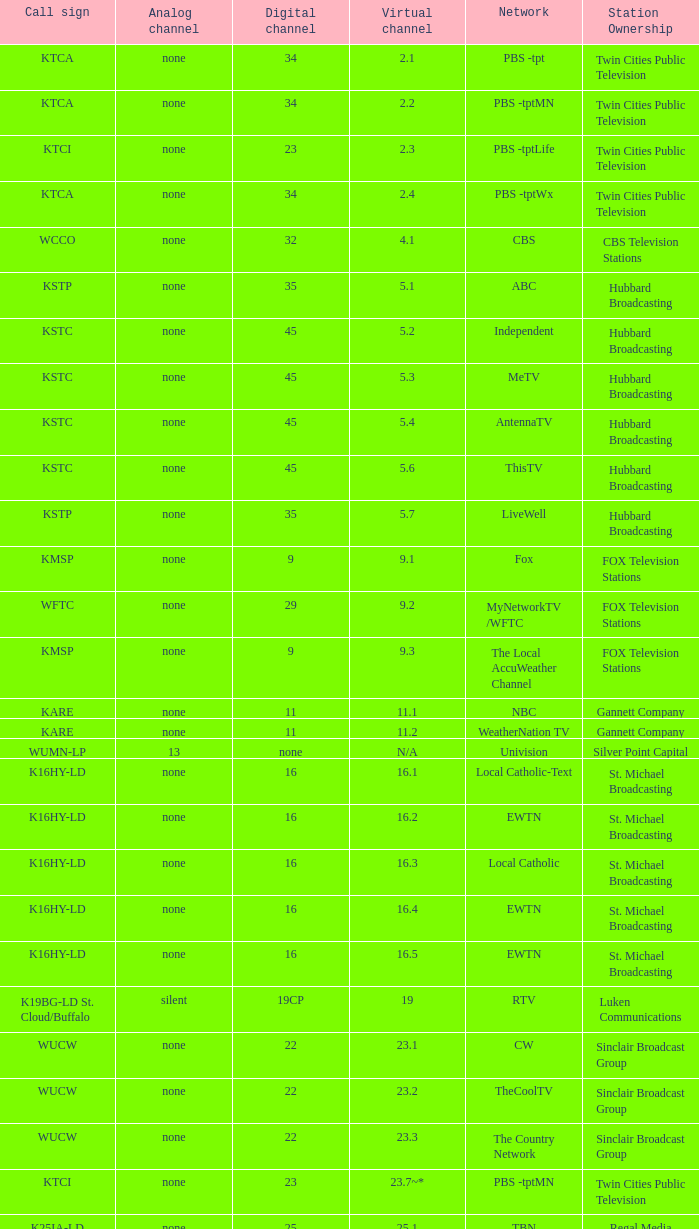Network of nbc is what digital channel? 11.0. Could you parse the entire table? {'header': ['Call sign', 'Analog channel', 'Digital channel', 'Virtual channel', 'Network', 'Station Ownership'], 'rows': [['KTCA', 'none', '34', '2.1', 'PBS -tpt', 'Twin Cities Public Television'], ['KTCA', 'none', '34', '2.2', 'PBS -tptMN', 'Twin Cities Public Television'], ['KTCI', 'none', '23', '2.3', 'PBS -tptLife', 'Twin Cities Public Television'], ['KTCA', 'none', '34', '2.4', 'PBS -tptWx', 'Twin Cities Public Television'], ['WCCO', 'none', '32', '4.1', 'CBS', 'CBS Television Stations'], ['KSTP', 'none', '35', '5.1', 'ABC', 'Hubbard Broadcasting'], ['KSTC', 'none', '45', '5.2', 'Independent', 'Hubbard Broadcasting'], ['KSTC', 'none', '45', '5.3', 'MeTV', 'Hubbard Broadcasting'], ['KSTC', 'none', '45', '5.4', 'AntennaTV', 'Hubbard Broadcasting'], ['KSTC', 'none', '45', '5.6', 'ThisTV', 'Hubbard Broadcasting'], ['KSTP', 'none', '35', '5.7', 'LiveWell', 'Hubbard Broadcasting'], ['KMSP', 'none', '9', '9.1', 'Fox', 'FOX Television Stations'], ['WFTC', 'none', '29', '9.2', 'MyNetworkTV /WFTC', 'FOX Television Stations'], ['KMSP', 'none', '9', '9.3', 'The Local AccuWeather Channel', 'FOX Television Stations'], ['KARE', 'none', '11', '11.1', 'NBC', 'Gannett Company'], ['KARE', 'none', '11', '11.2', 'WeatherNation TV', 'Gannett Company'], ['WUMN-LP', '13', 'none', 'N/A', 'Univision', 'Silver Point Capital'], ['K16HY-LD', 'none', '16', '16.1', 'Local Catholic-Text', 'St. Michael Broadcasting'], ['K16HY-LD', 'none', '16', '16.2', 'EWTN', 'St. Michael Broadcasting'], ['K16HY-LD', 'none', '16', '16.3', 'Local Catholic', 'St. Michael Broadcasting'], ['K16HY-LD', 'none', '16', '16.4', 'EWTN', 'St. Michael Broadcasting'], ['K16HY-LD', 'none', '16', '16.5', 'EWTN', 'St. Michael Broadcasting'], ['K19BG-LD St. Cloud/Buffalo', 'silent', '19CP', '19', 'RTV', 'Luken Communications'], ['WUCW', 'none', '22', '23.1', 'CW', 'Sinclair Broadcast Group'], ['WUCW', 'none', '22', '23.2', 'TheCoolTV', 'Sinclair Broadcast Group'], ['WUCW', 'none', '22', '23.3', 'The Country Network', 'Sinclair Broadcast Group'], ['KTCI', 'none', '23', '23.7~*', 'PBS -tptMN', 'Twin Cities Public Television'], ['K25IA-LD', 'none', '25', '25.1', 'TBN', 'Regal Media'], ['K25IA-LD', 'none', '25', '25.2', 'The Church Channel', 'Regal Media'], ['K25IA-LD', 'none', '25', '25.3', 'JCTV', 'Regal Media'], ['K25IA-LD', 'none', '25', '25.4', 'Smile Of A Child', 'Regal Media'], ['K25IA-LD', 'none', '25', '25.5', 'TBN Enlace', 'Regal Media'], ['W47CO-LD River Falls, Wisc.', 'none', '47', '28.1', 'PBS /WHWC', 'Wisconsin Public Television'], ['W47CO-LD River Falls, Wisc.', 'none', '47', '28.2', 'PBS -WISC/WHWC', 'Wisconsin Public Television'], ['W47CO-LD River Falls, Wisc.', 'none', '47', '28.3', 'PBS -Create/WHWC', 'Wisconsin Public Television'], ['WFTC', 'none', '29', '29.1', 'MyNetworkTV', 'FOX Television Stations'], ['KMSP', 'none', '9', '29.2', 'MyNetworkTV /WFTC', 'FOX Television Stations'], ['WFTC', 'none', '29', '29.3', 'Bounce TV', 'FOX Television Stations'], ['WFTC', 'none', '29', '29.4', 'Movies!', 'FOX Television Stations'], ['K33LN-LD', 'none', '33', '33.1', '3ABN', 'Three Angels Broadcasting Network'], ['K33LN-LD', 'none', '33', '33.2', '3ABN Proclaim!', 'Three Angels Broadcasting Network'], ['K33LN-LD', 'none', '33', '33.3', '3ABN Dare to Dream', 'Three Angels Broadcasting Network'], ['K33LN-LD', 'none', '33', '33.4', '3ABN Latino', 'Three Angels Broadcasting Network'], ['K33LN-LD', 'none', '33', '33.5', '3ABN Radio-Audio', 'Three Angels Broadcasting Network'], ['K33LN-LD', 'none', '33', '33.6', '3ABN Radio Latino-Audio', 'Three Angels Broadcasting Network'], ['K33LN-LD', 'none', '33', '33.7', 'Radio 74-Audio', 'Three Angels Broadcasting Network'], ['KPXM-TV', 'none', '40', '41.1', 'Ion Television', 'Ion Media Networks'], ['KPXM-TV', 'none', '40', '41.2', 'Qubo Kids', 'Ion Media Networks'], ['KPXM-TV', 'none', '40', '41.3', 'Ion Life', 'Ion Media Networks'], ['K43HB-LD', 'none', '43', '43.1', 'HSN', 'Ventana Television'], ['KHVM-LD', 'none', '48', '48.1', 'GCN - Religious', 'EICB TV'], ['KTCJ-LD', 'none', '50', '50.1', 'CTVN - Religious', 'EICB TV'], ['WDMI-LD', 'none', '31', '62.1', 'Daystar', 'Word of God Fellowship']]} 